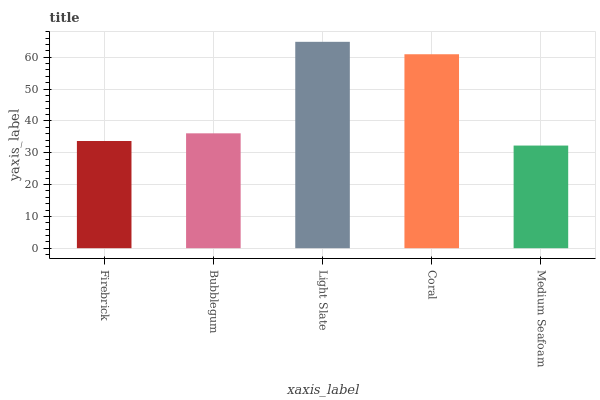Is Bubblegum the minimum?
Answer yes or no. No. Is Bubblegum the maximum?
Answer yes or no. No. Is Bubblegum greater than Firebrick?
Answer yes or no. Yes. Is Firebrick less than Bubblegum?
Answer yes or no. Yes. Is Firebrick greater than Bubblegum?
Answer yes or no. No. Is Bubblegum less than Firebrick?
Answer yes or no. No. Is Bubblegum the high median?
Answer yes or no. Yes. Is Bubblegum the low median?
Answer yes or no. Yes. Is Medium Seafoam the high median?
Answer yes or no. No. Is Coral the low median?
Answer yes or no. No. 